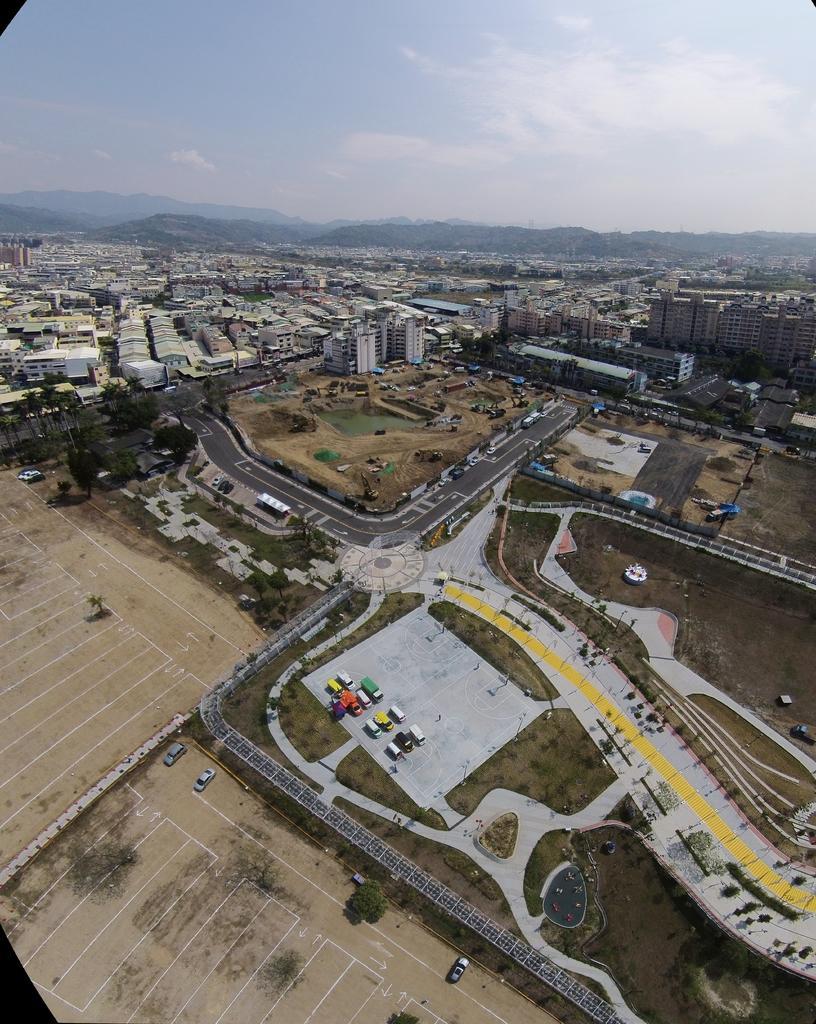Can you describe this image briefly? In the image we can see some buildings and vehicles and trees and hills. At the top of the image there are some clouds and sky. 